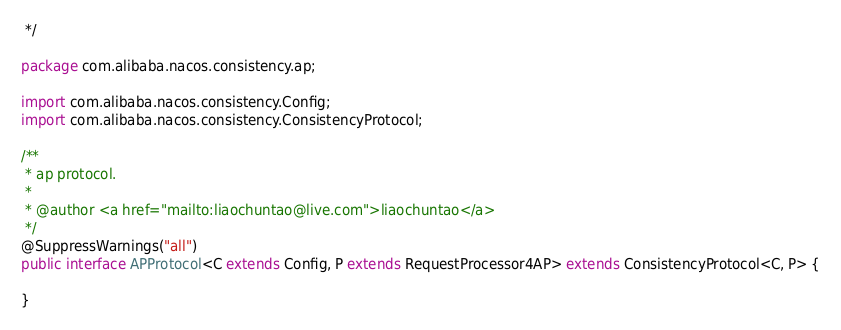<code> <loc_0><loc_0><loc_500><loc_500><_Java_> */

package com.alibaba.nacos.consistency.ap;

import com.alibaba.nacos.consistency.Config;
import com.alibaba.nacos.consistency.ConsistencyProtocol;

/**
 * ap protocol.
 *
 * @author <a href="mailto:liaochuntao@live.com">liaochuntao</a>
 */
@SuppressWarnings("all")
public interface APProtocol<C extends Config, P extends RequestProcessor4AP> extends ConsistencyProtocol<C, P> {

}
</code> 